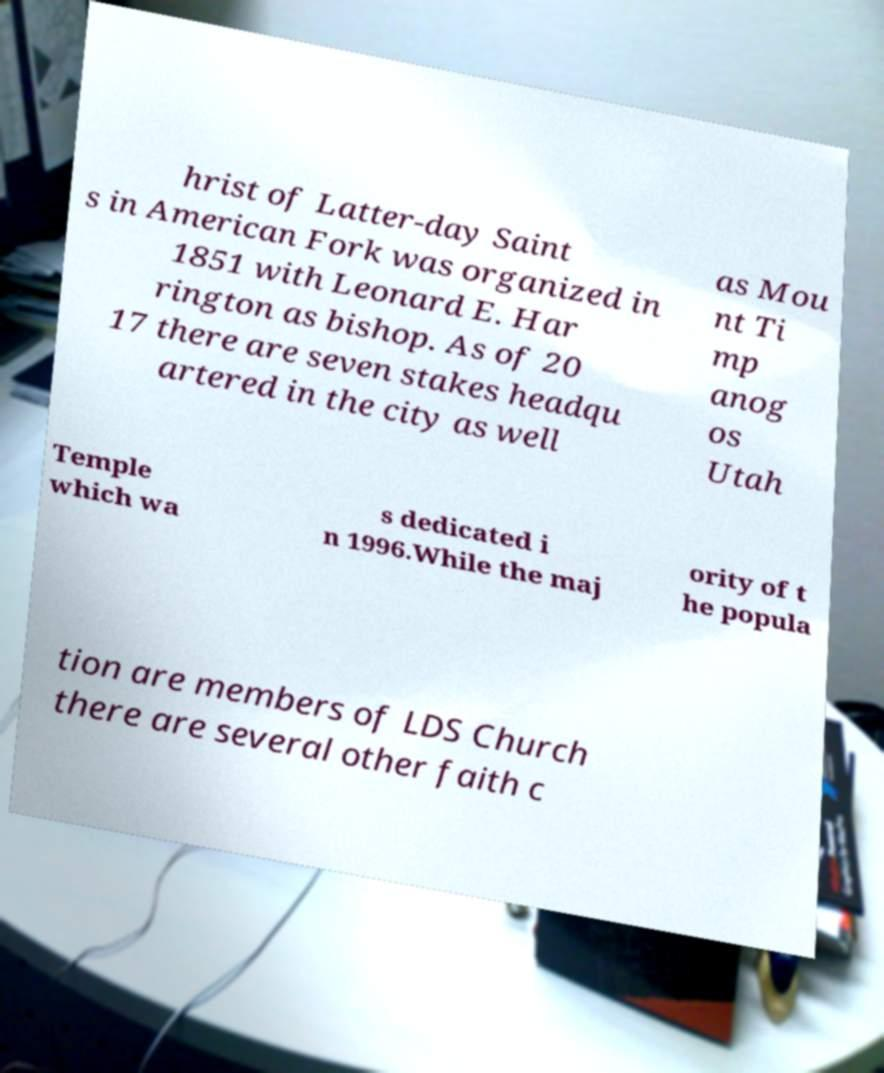Could you assist in decoding the text presented in this image and type it out clearly? hrist of Latter-day Saint s in American Fork was organized in 1851 with Leonard E. Har rington as bishop. As of 20 17 there are seven stakes headqu artered in the city as well as Mou nt Ti mp anog os Utah Temple which wa s dedicated i n 1996.While the maj ority of t he popula tion are members of LDS Church there are several other faith c 